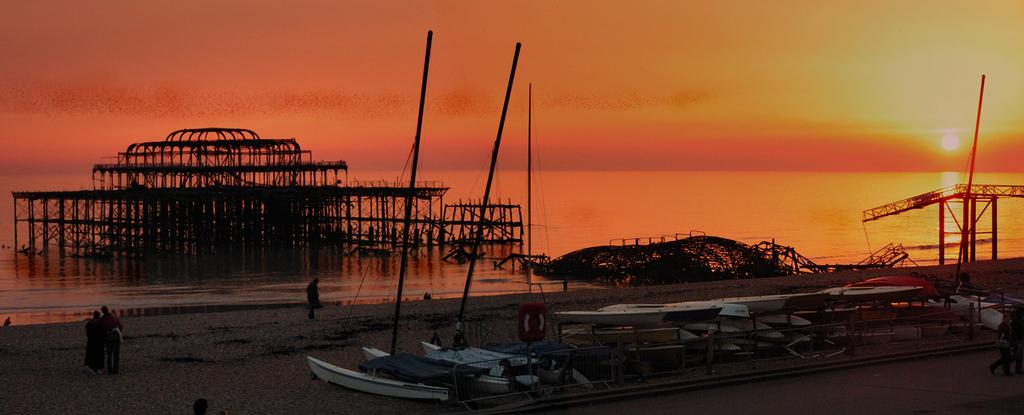What is visible in the center of the image? The sky is visible in the center of the image. What celestial body can be seen in the sky? The sun is present in the image. What type of landscape is depicted in the image? There is water in the image, suggesting a water body or coastline. What are the boats used for in the image? Boats are present in the image, which might indicate that people are using them for transportation or leisure activities. What are the poles used for in the image? Poles are visible in the image, but their purpose cannot be determined without additional context. Who or what is present in the image? There are people in the image. Can you describe any other objects in the image? There are a few other objects in the image, but their specific nature cannot be determined without additional context. What type of action is the home performing in the image? There is no home present in the image, so it cannot perform any actions. What is inside the box in the image? There is no box present in the image. 